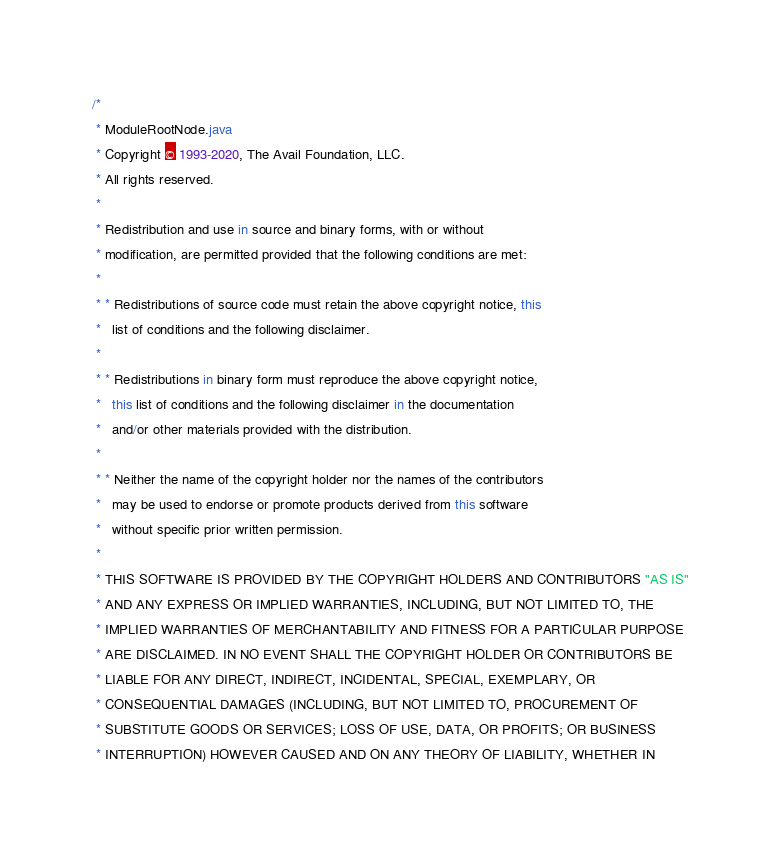Convert code to text. <code><loc_0><loc_0><loc_500><loc_500><_Kotlin_>/*
 * ModuleRootNode.java
 * Copyright © 1993-2020, The Avail Foundation, LLC.
 * All rights reserved.
 *
 * Redistribution and use in source and binary forms, with or without
 * modification, are permitted provided that the following conditions are met:
 *
 * * Redistributions of source code must retain the above copyright notice, this
 *   list of conditions and the following disclaimer.
 *
 * * Redistributions in binary form must reproduce the above copyright notice,
 *   this list of conditions and the following disclaimer in the documentation
 *   and/or other materials provided with the distribution.
 *
 * * Neither the name of the copyright holder nor the names of the contributors
 *   may be used to endorse or promote products derived from this software
 *   without specific prior written permission.
 *
 * THIS SOFTWARE IS PROVIDED BY THE COPYRIGHT HOLDERS AND CONTRIBUTORS "AS IS"
 * AND ANY EXPRESS OR IMPLIED WARRANTIES, INCLUDING, BUT NOT LIMITED TO, THE
 * IMPLIED WARRANTIES OF MERCHANTABILITY AND FITNESS FOR A PARTICULAR PURPOSE
 * ARE DISCLAIMED. IN NO EVENT SHALL THE COPYRIGHT HOLDER OR CONTRIBUTORS BE
 * LIABLE FOR ANY DIRECT, INDIRECT, INCIDENTAL, SPECIAL, EXEMPLARY, OR
 * CONSEQUENTIAL DAMAGES (INCLUDING, BUT NOT LIMITED TO, PROCUREMENT OF
 * SUBSTITUTE GOODS OR SERVICES; LOSS OF USE, DATA, OR PROFITS; OR BUSINESS
 * INTERRUPTION) HOWEVER CAUSED AND ON ANY THEORY OF LIABILITY, WHETHER IN</code> 